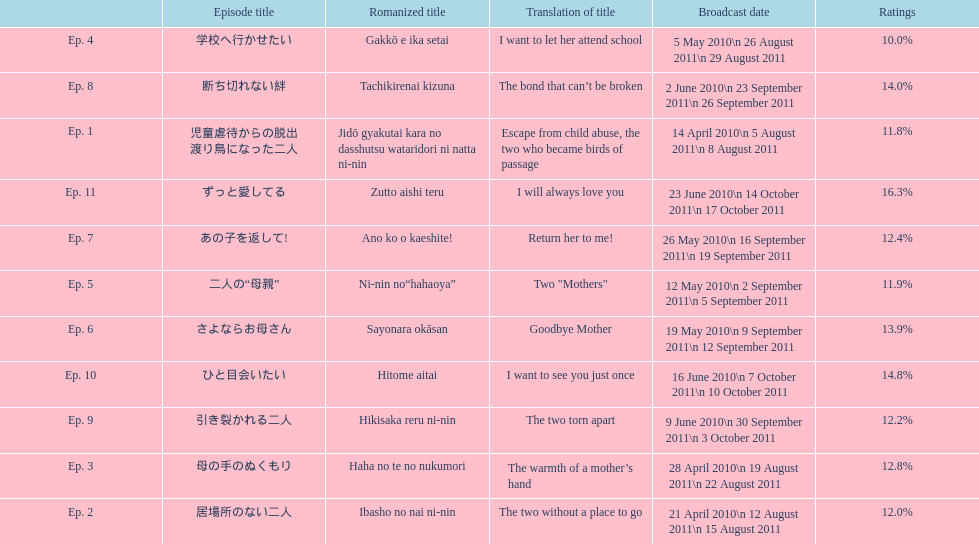Can you parse all the data within this table? {'header': ['', 'Episode title', 'Romanized title', 'Translation of title', 'Broadcast date', 'Ratings'], 'rows': [['Ep. 4', '学校へ行かせたい', 'Gakkō e ika setai', 'I want to let her attend school', '5 May 2010\\n 26 August 2011\\n 29 August 2011', '10.0%'], ['Ep. 8', '断ち切れない絆', 'Tachikirenai kizuna', 'The bond that can’t be broken', '2 June 2010\\n 23 September 2011\\n 26 September 2011', '14.0%'], ['Ep. 1', '児童虐待からの脱出 渡り鳥になった二人', 'Jidō gyakutai kara no dasshutsu wataridori ni natta ni-nin', 'Escape from child abuse, the two who became birds of passage', '14 April 2010\\n 5 August 2011\\n 8 August 2011', '11.8%'], ['Ep. 11', 'ずっと愛してる', 'Zutto aishi teru', 'I will always love you', '23 June 2010\\n 14 October 2011\\n 17 October 2011', '16.3%'], ['Ep. 7', 'あの子を返して!', 'Ano ko o kaeshite!', 'Return her to me!', '26 May 2010\\n 16 September 2011\\n 19 September 2011', '12.4%'], ['Ep. 5', '二人の“母親”', 'Ni-nin no“hahaoya”', 'Two "Mothers"', '12 May 2010\\n 2 September 2011\\n 5 September 2011', '11.9%'], ['Ep. 6', 'さよならお母さん', 'Sayonara okāsan', 'Goodbye Mother', '19 May 2010\\n 9 September 2011\\n 12 September 2011', '13.9%'], ['Ep. 10', 'ひと目会いたい', 'Hitome aitai', 'I want to see you just once', '16 June 2010\\n 7 October 2011\\n 10 October 2011', '14.8%'], ['Ep. 9', '引き裂かれる二人', 'Hikisaka reru ni-nin', 'The two torn apart', '9 June 2010\\n 30 September 2011\\n 3 October 2011', '12.2%'], ['Ep. 3', '母の手のぬくもり', 'Haha no te no nukumori', 'The warmth of a mother’s hand', '28 April 2010\\n 19 August 2011\\n 22 August 2011', '12.8%'], ['Ep. 2', '居場所のない二人', 'Ibasho no nai ni-nin', 'The two without a place to go', '21 April 2010\\n 12 August 2011\\n 15 August 2011', '12.0%']]} What as the percentage total of ratings for episode 8? 14.0%. 